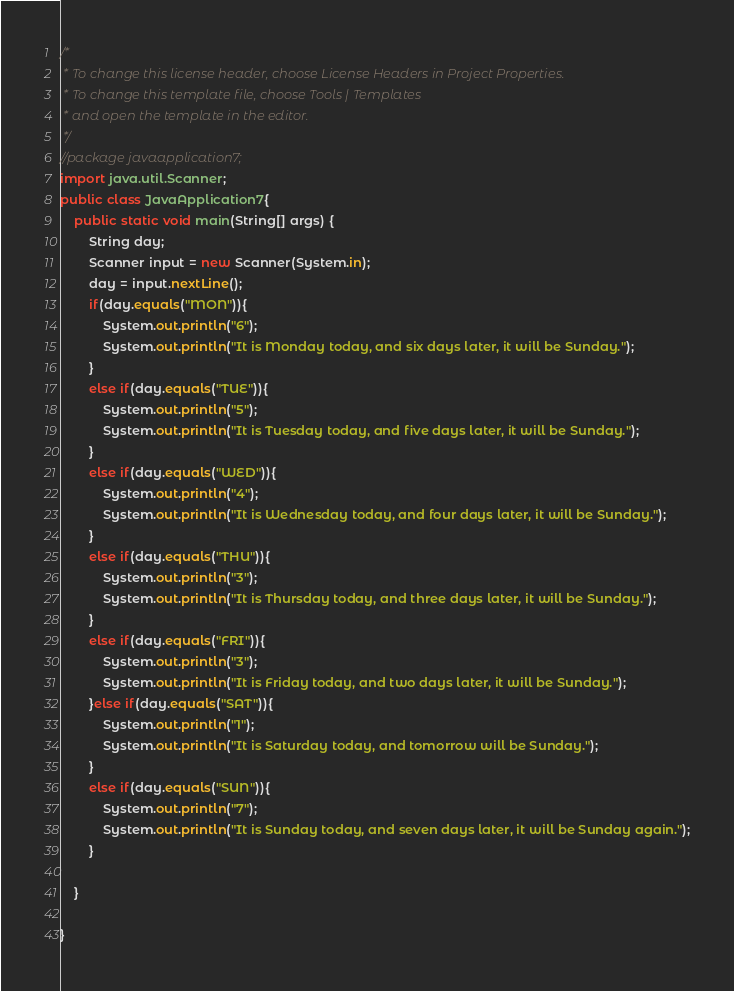<code> <loc_0><loc_0><loc_500><loc_500><_Java_>/*
 * To change this license header, choose License Headers in Project Properties.
 * To change this template file, choose Tools | Templates
 * and open the template in the editor.
 */
//package javaapplication7;
import java.util.Scanner;
public class JavaApplication7{
    public static void main(String[] args) {
        String day;
        Scanner input = new Scanner(System.in);
        day = input.nextLine();
        if(day.equals("MON")){
            System.out.println("6");
            System.out.println("It is Monday today, and six days later, it will be Sunday.");
        }
        else if(day.equals("TUE")){
            System.out.println("5");
            System.out.println("It is Tuesday today, and five days later, it will be Sunday.");
        }
        else if(day.equals("WED")){
            System.out.println("4");
            System.out.println("It is Wednesday today, and four days later, it will be Sunday.");
        }
        else if(day.equals("THU")){
            System.out.println("3");
            System.out.println("It is Thursday today, and three days later, it will be Sunday.");
        }
        else if(day.equals("FRI")){
            System.out.println("3");
            System.out.println("It is Friday today, and two days later, it will be Sunday.");
        }else if(day.equals("SAT")){
            System.out.println("1");
            System.out.println("It is Saturday today, and tomorrow will be Sunday.");
        }
        else if(day.equals("SUN")){
            System.out.println("7");
            System.out.println("It is Sunday today, and seven days later, it will be Sunday again.");
        }
        
    }
    
}
</code> 